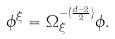Convert formula to latex. <formula><loc_0><loc_0><loc_500><loc_500>\phi ^ { \xi } = \Omega _ { \xi } ^ { - ( \frac { d - 2 } { 2 } ) } \phi .</formula> 